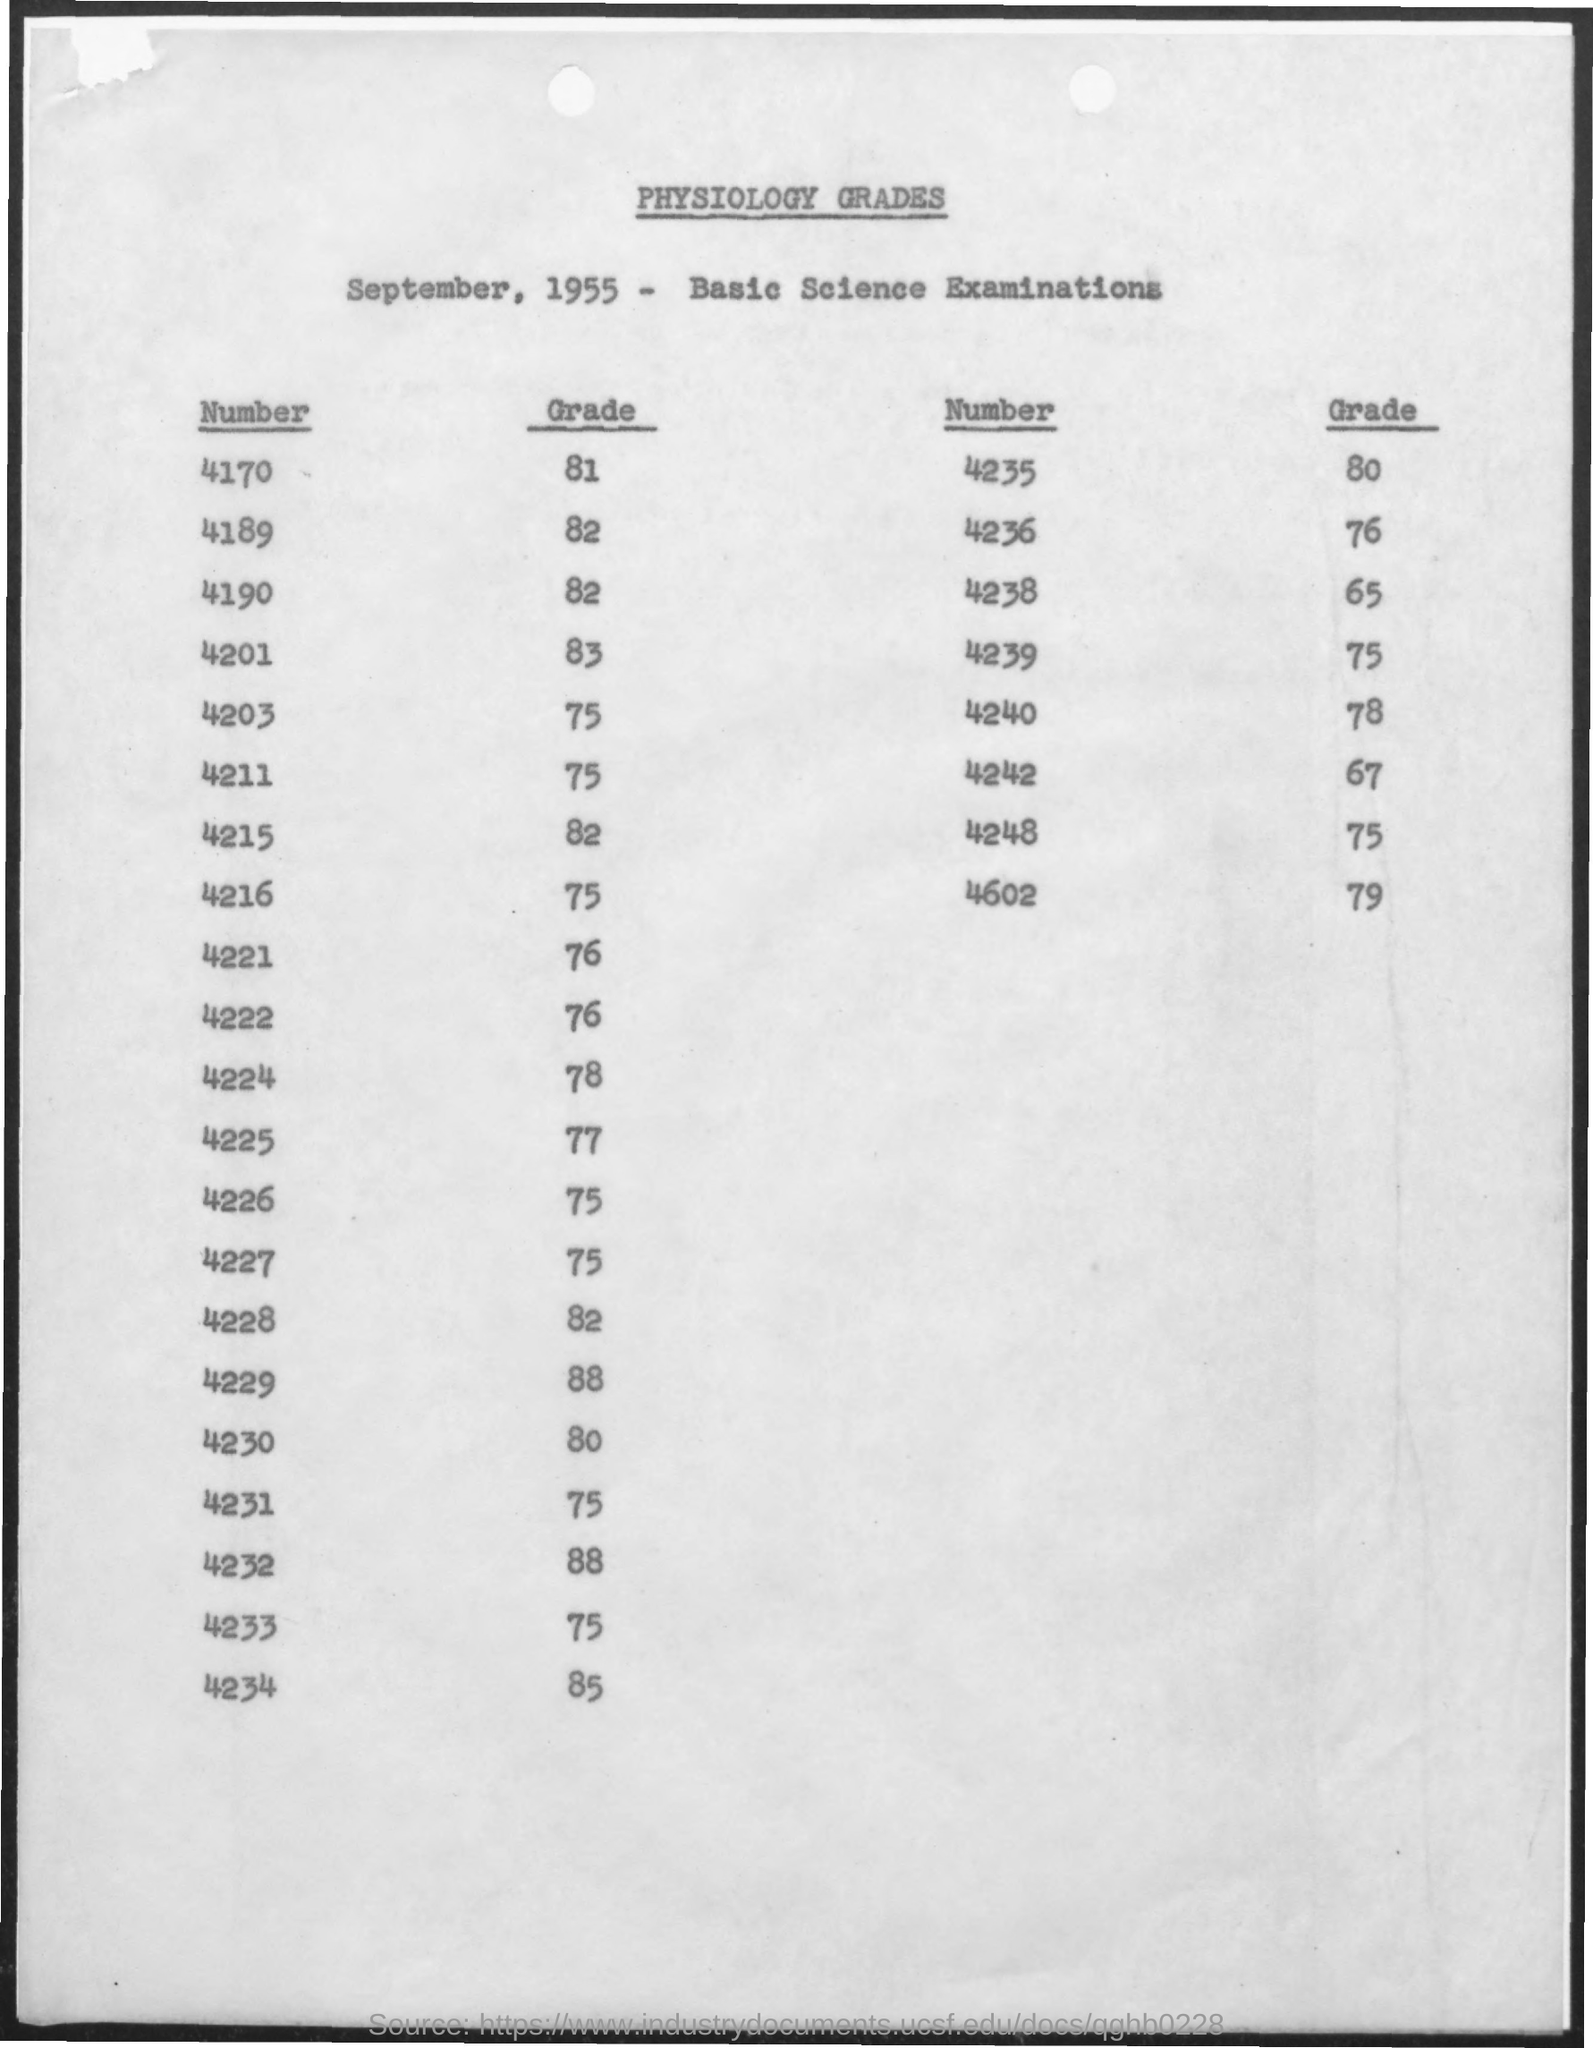What is the heading?
Offer a terse response. Physiology grades. Which examination is it?
Keep it short and to the point. Basic science. Which year is mentioned?
Provide a succinct answer. 1955. What is the grade of number 4170?
Your response must be concise. 81. 